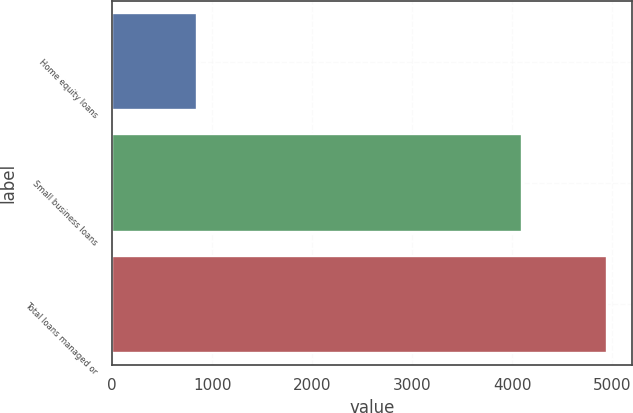Convert chart. <chart><loc_0><loc_0><loc_500><loc_500><bar_chart><fcel>Home equity loans<fcel>Small business loans<fcel>Total loans managed or<nl><fcel>852.5<fcel>4093.5<fcel>4946<nl></chart> 